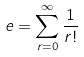<formula> <loc_0><loc_0><loc_500><loc_500>e = \sum _ { r = 0 } ^ { \infty } \frac { 1 } { r ! }</formula> 